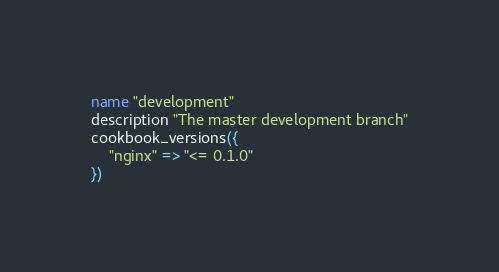<code> <loc_0><loc_0><loc_500><loc_500><_Ruby_>name "development"
description "The master development branch"
cookbook_versions({
    "nginx" => "<= 0.1.0"
})</code> 